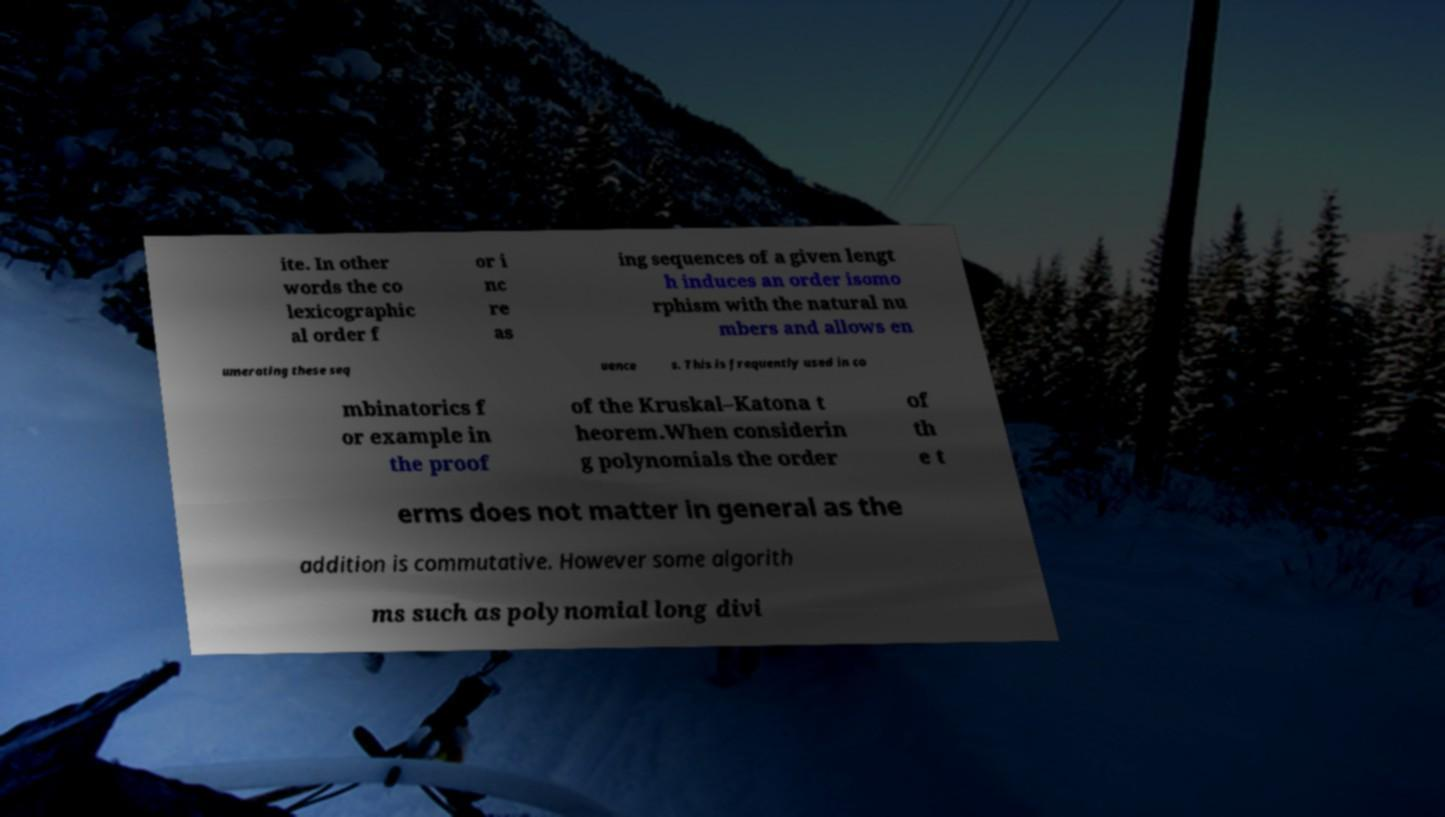What messages or text are displayed in this image? I need them in a readable, typed format. ite. In other words the co lexicographic al order f or i nc re as ing sequences of a given lengt h induces an order isomo rphism with the natural nu mbers and allows en umerating these seq uence s. This is frequently used in co mbinatorics f or example in the proof of the Kruskal–Katona t heorem.When considerin g polynomials the order of th e t erms does not matter in general as the addition is commutative. However some algorith ms such as polynomial long divi 